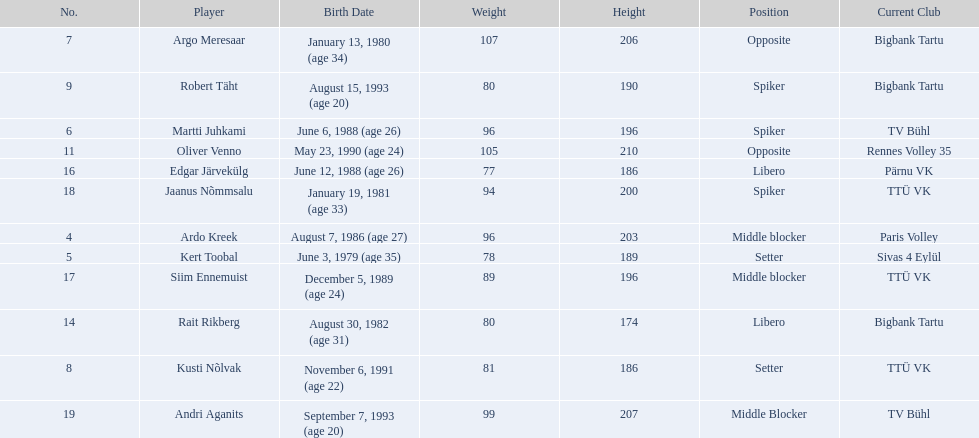How much taller in oliver venno than rait rikberg? 36. 